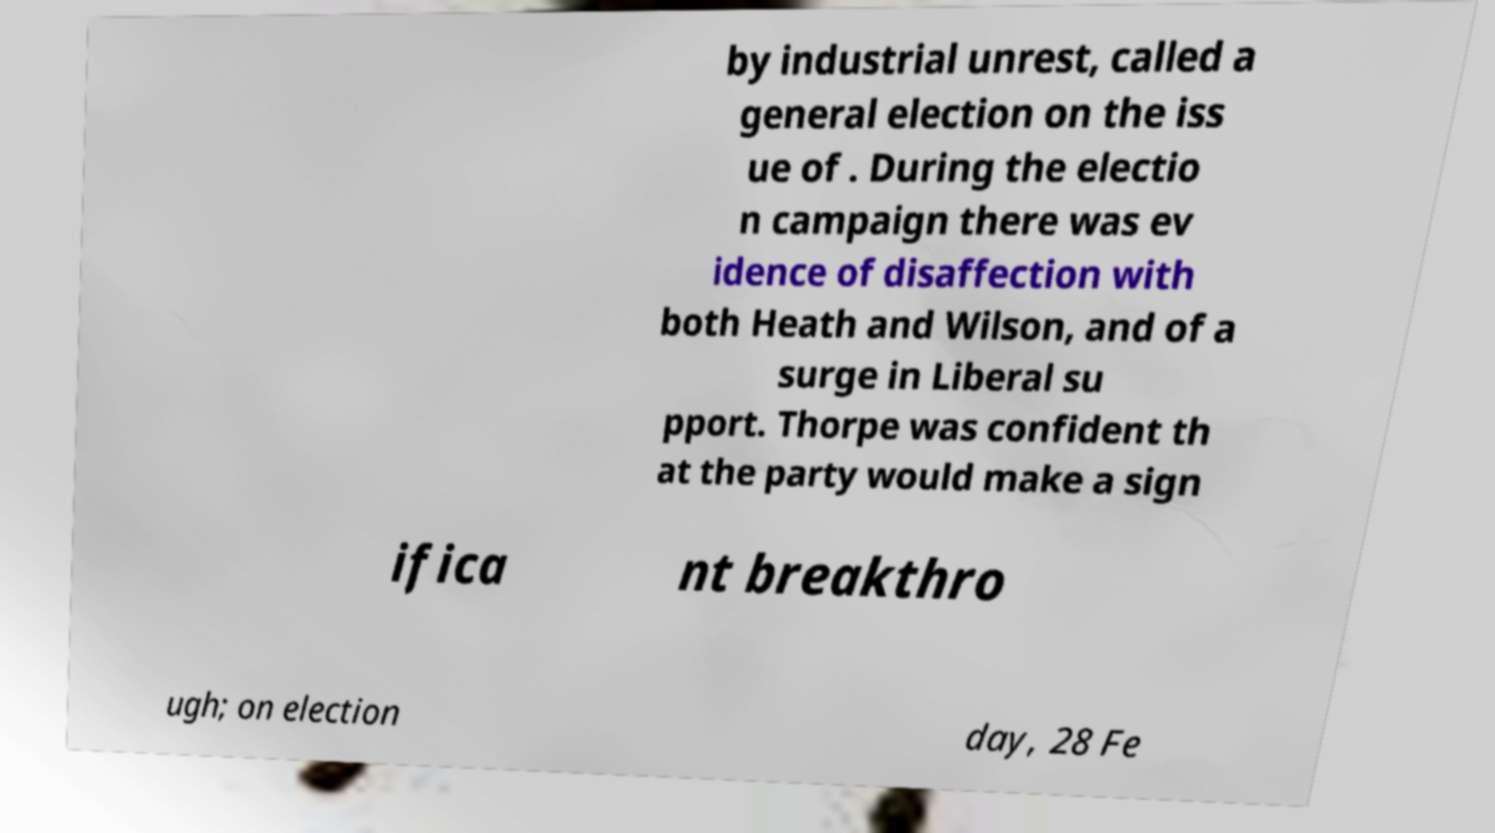Please read and relay the text visible in this image. What does it say? by industrial unrest, called a general election on the iss ue of . During the electio n campaign there was ev idence of disaffection with both Heath and Wilson, and of a surge in Liberal su pport. Thorpe was confident th at the party would make a sign ifica nt breakthro ugh; on election day, 28 Fe 